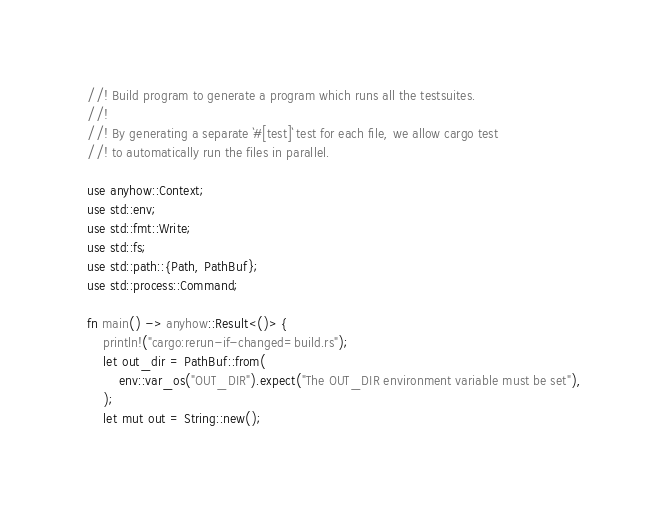<code> <loc_0><loc_0><loc_500><loc_500><_Rust_>//! Build program to generate a program which runs all the testsuites.
//!
//! By generating a separate `#[test]` test for each file, we allow cargo test
//! to automatically run the files in parallel.

use anyhow::Context;
use std::env;
use std::fmt::Write;
use std::fs;
use std::path::{Path, PathBuf};
use std::process::Command;

fn main() -> anyhow::Result<()> {
    println!("cargo:rerun-if-changed=build.rs");
    let out_dir = PathBuf::from(
        env::var_os("OUT_DIR").expect("The OUT_DIR environment variable must be set"),
    );
    let mut out = String::new();
</code> 